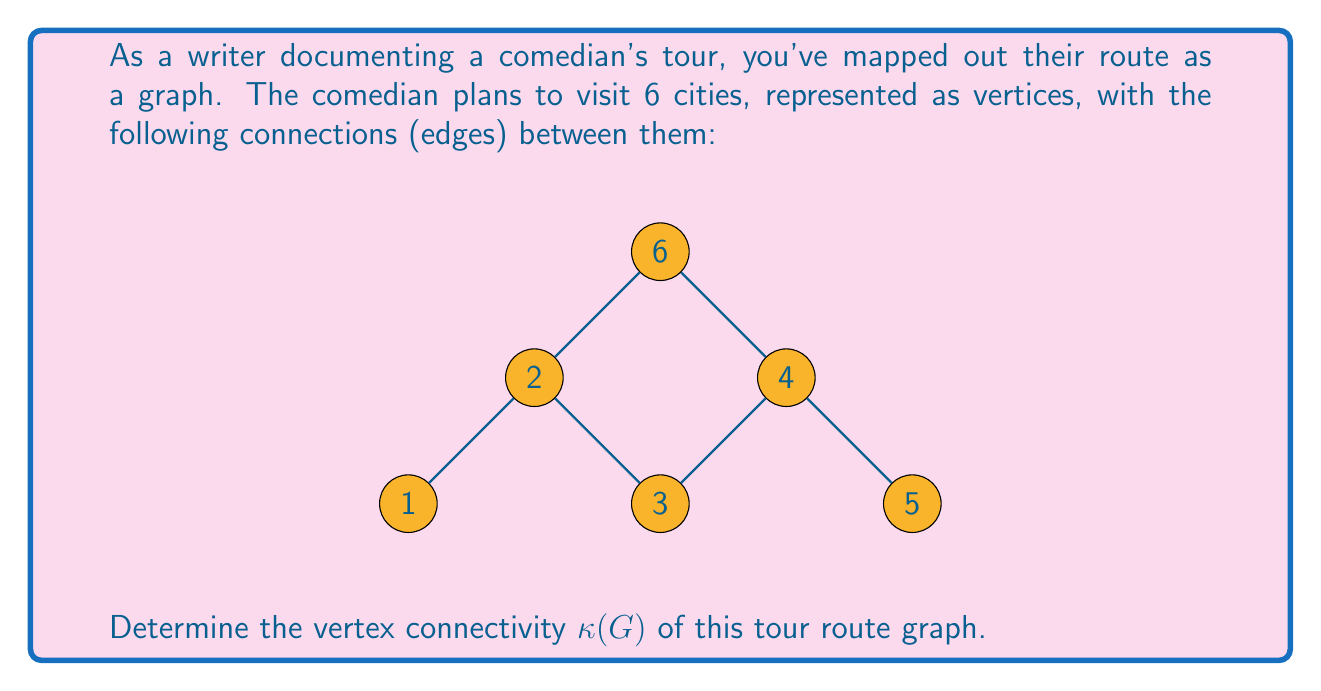What is the answer to this math problem? To find the vertex connectivity $\kappa(G)$ of the graph, we need to determine the minimum number of vertices that need to be removed to disconnect the graph or reduce it to a single vertex.

Step 1: Analyze the graph structure
- The graph has 6 vertices and 6 edges.
- It forms a path-like structure with an additional vertex (6) connected to vertices 2 and 4.

Step 2: Identify critical vertices
- Removing vertex 2 or 4 would disconnect the graph into three components.
- Removing any other single vertex would not disconnect the graph.

Step 3: Consider pairs of vertices
- Removing vertices 1 and 3 would disconnect the graph.
- Removing vertices 3 and 5 would disconnect the graph.
- Other pairs of vertices would either not disconnect the graph or would reduce it to a single vertex.

Step 4: Determine the vertex connectivity
- Since removing a single vertex can disconnect the graph, and we found the minimum number of vertices to be 1, the vertex connectivity $\kappa(G) = 1$.

Definition: The vertex connectivity of a graph is the minimum number of vertices whose removal results in a disconnected graph or a graph with a single vertex.
Answer: $\kappa(G) = 1$ 